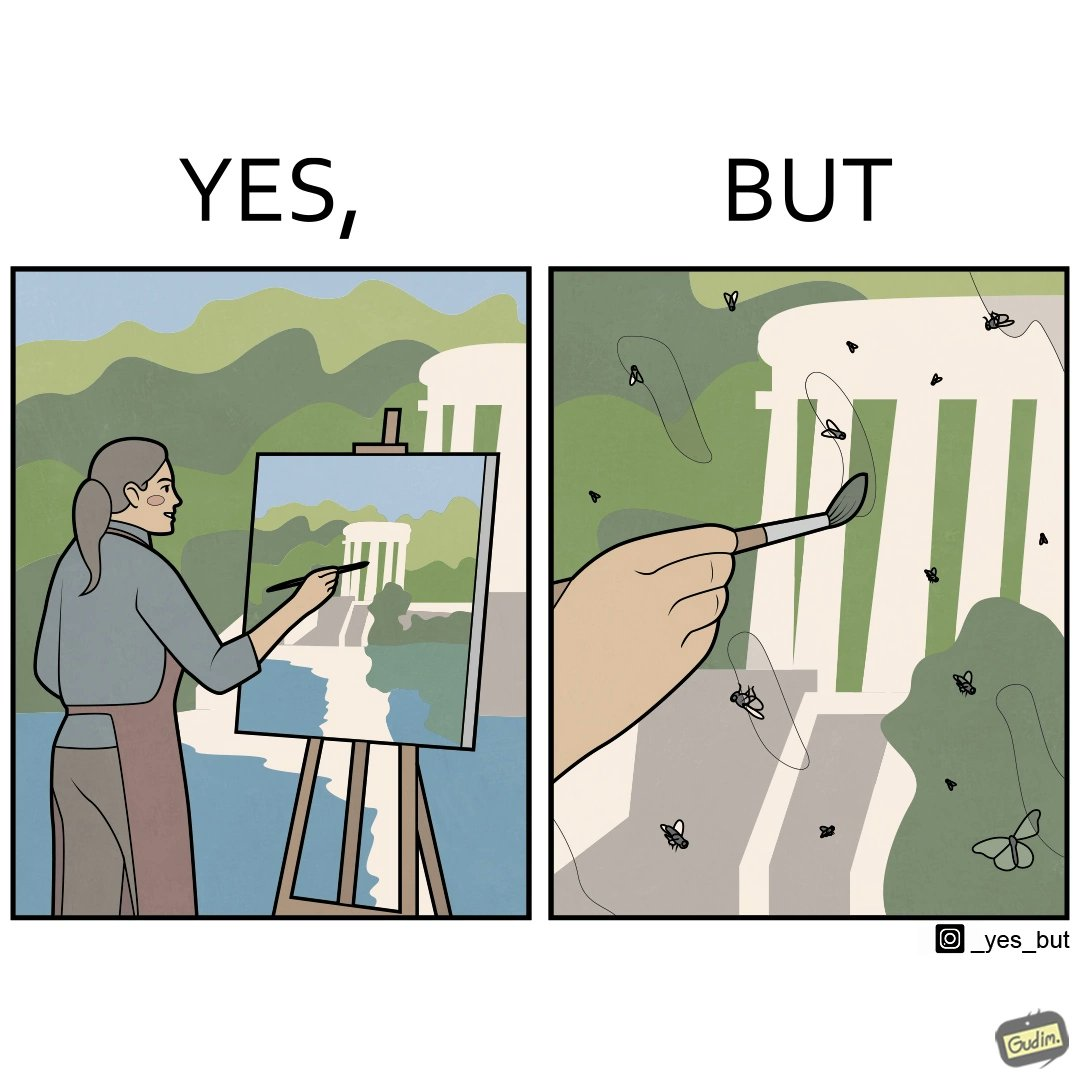Why is this image considered satirical? The images are funny since they show how a peaceful sight like a woman painting a natural scenery looks good only from afar. When looked closely we can see details like flies on the painting which make us uneasy and the scene is not so good to look at anymore. 